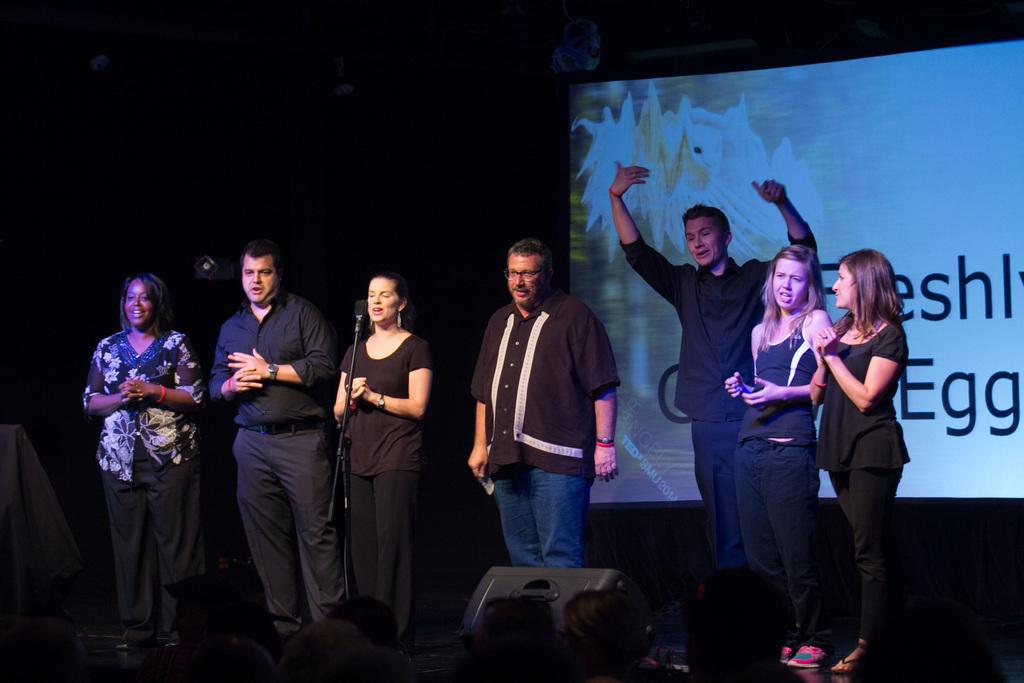How would you summarize this image in a sentence or two? In the image there are few men and women standing on stage in black dress and behind them there is a screen. 